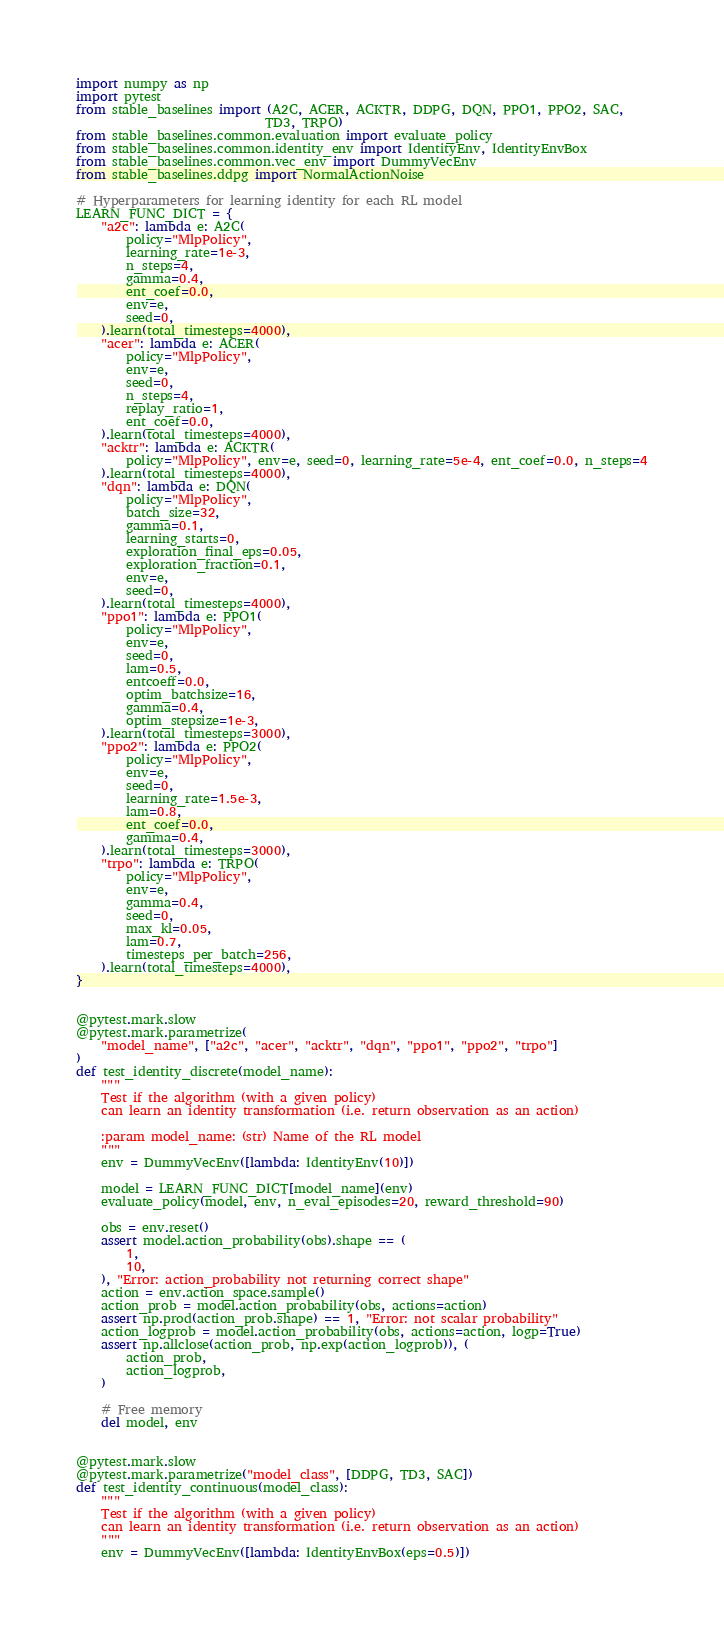<code> <loc_0><loc_0><loc_500><loc_500><_Python_>import numpy as np
import pytest
from stable_baselines import (A2C, ACER, ACKTR, DDPG, DQN, PPO1, PPO2, SAC,
                              TD3, TRPO)
from stable_baselines.common.evaluation import evaluate_policy
from stable_baselines.common.identity_env import IdentityEnv, IdentityEnvBox
from stable_baselines.common.vec_env import DummyVecEnv
from stable_baselines.ddpg import NormalActionNoise

# Hyperparameters for learning identity for each RL model
LEARN_FUNC_DICT = {
    "a2c": lambda e: A2C(
        policy="MlpPolicy",
        learning_rate=1e-3,
        n_steps=4,
        gamma=0.4,
        ent_coef=0.0,
        env=e,
        seed=0,
    ).learn(total_timesteps=4000),
    "acer": lambda e: ACER(
        policy="MlpPolicy",
        env=e,
        seed=0,
        n_steps=4,
        replay_ratio=1,
        ent_coef=0.0,
    ).learn(total_timesteps=4000),
    "acktr": lambda e: ACKTR(
        policy="MlpPolicy", env=e, seed=0, learning_rate=5e-4, ent_coef=0.0, n_steps=4
    ).learn(total_timesteps=4000),
    "dqn": lambda e: DQN(
        policy="MlpPolicy",
        batch_size=32,
        gamma=0.1,
        learning_starts=0,
        exploration_final_eps=0.05,
        exploration_fraction=0.1,
        env=e,
        seed=0,
    ).learn(total_timesteps=4000),
    "ppo1": lambda e: PPO1(
        policy="MlpPolicy",
        env=e,
        seed=0,
        lam=0.5,
        entcoeff=0.0,
        optim_batchsize=16,
        gamma=0.4,
        optim_stepsize=1e-3,
    ).learn(total_timesteps=3000),
    "ppo2": lambda e: PPO2(
        policy="MlpPolicy",
        env=e,
        seed=0,
        learning_rate=1.5e-3,
        lam=0.8,
        ent_coef=0.0,
        gamma=0.4,
    ).learn(total_timesteps=3000),
    "trpo": lambda e: TRPO(
        policy="MlpPolicy",
        env=e,
        gamma=0.4,
        seed=0,
        max_kl=0.05,
        lam=0.7,
        timesteps_per_batch=256,
    ).learn(total_timesteps=4000),
}


@pytest.mark.slow
@pytest.mark.parametrize(
    "model_name", ["a2c", "acer", "acktr", "dqn", "ppo1", "ppo2", "trpo"]
)
def test_identity_discrete(model_name):
    """
    Test if the algorithm (with a given policy)
    can learn an identity transformation (i.e. return observation as an action)

    :param model_name: (str) Name of the RL model
    """
    env = DummyVecEnv([lambda: IdentityEnv(10)])

    model = LEARN_FUNC_DICT[model_name](env)
    evaluate_policy(model, env, n_eval_episodes=20, reward_threshold=90)

    obs = env.reset()
    assert model.action_probability(obs).shape == (
        1,
        10,
    ), "Error: action_probability not returning correct shape"
    action = env.action_space.sample()
    action_prob = model.action_probability(obs, actions=action)
    assert np.prod(action_prob.shape) == 1, "Error: not scalar probability"
    action_logprob = model.action_probability(obs, actions=action, logp=True)
    assert np.allclose(action_prob, np.exp(action_logprob)), (
        action_prob,
        action_logprob,
    )

    # Free memory
    del model, env


@pytest.mark.slow
@pytest.mark.parametrize("model_class", [DDPG, TD3, SAC])
def test_identity_continuous(model_class):
    """
    Test if the algorithm (with a given policy)
    can learn an identity transformation (i.e. return observation as an action)
    """
    env = DummyVecEnv([lambda: IdentityEnvBox(eps=0.5)])
</code> 